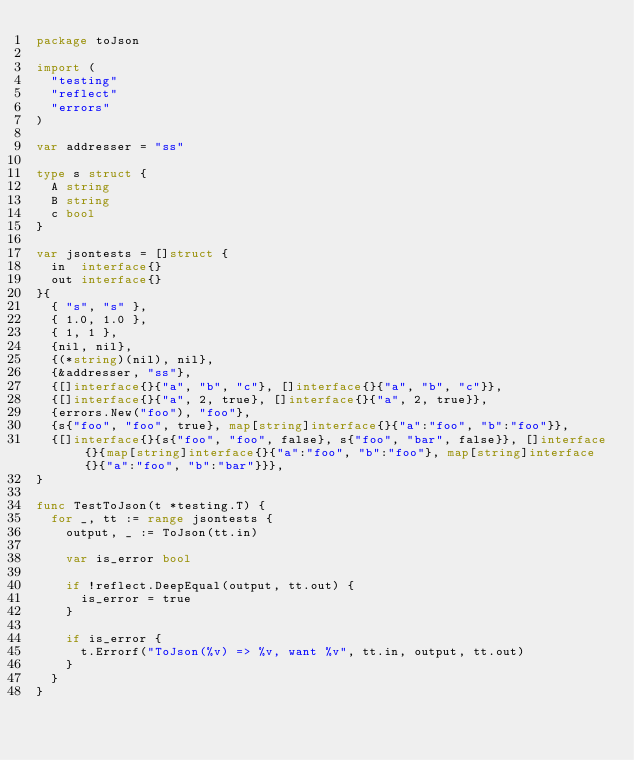Convert code to text. <code><loc_0><loc_0><loc_500><loc_500><_Go_>package toJson

import (
	"testing"
	"reflect"
	"errors"
)

var addresser = "ss"

type s struct {
	A string
	B string
	c bool
}

var jsontests = []struct {
	in  interface{}
	out interface{}
}{
	{ "s", "s" },
	{ 1.0, 1.0 },
	{ 1, 1 },
	{nil, nil},
	{(*string)(nil), nil},
	{&addresser, "ss"},
	{[]interface{}{"a", "b", "c"}, []interface{}{"a", "b", "c"}},
	{[]interface{}{"a", 2, true}, []interface{}{"a", 2, true}},
	{errors.New("foo"), "foo"},
	{s{"foo", "foo", true}, map[string]interface{}{"a":"foo", "b":"foo"}},
	{[]interface{}{s{"foo", "foo", false}, s{"foo", "bar", false}}, []interface{}{map[string]interface{}{"a":"foo", "b":"foo"}, map[string]interface{}{"a":"foo", "b":"bar"}}},
}

func TestToJson(t *testing.T) {
	for _, tt := range jsontests {
		output, _ := ToJson(tt.in)

		var is_error bool

		if !reflect.DeepEqual(output, tt.out) {
			is_error = true
		}

		if is_error {
			t.Errorf("ToJson(%v) => %v, want %v", tt.in, output, tt.out)
		}
	}
}
</code> 